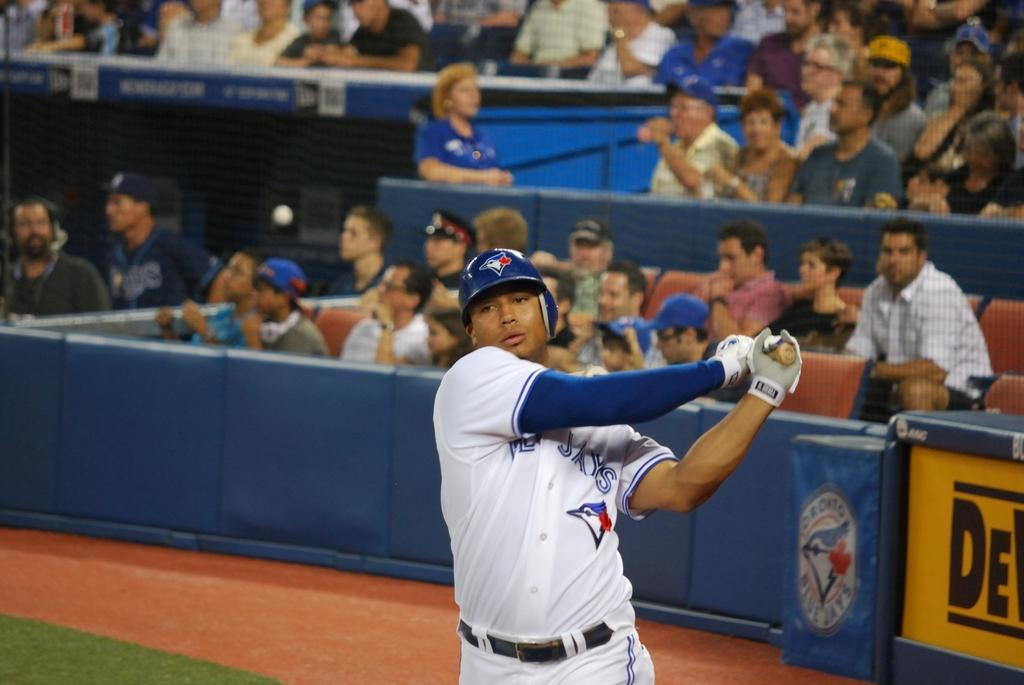<image>
Relay a brief, clear account of the picture shown. Baseball player for the Blue Jays hitting the ball. 